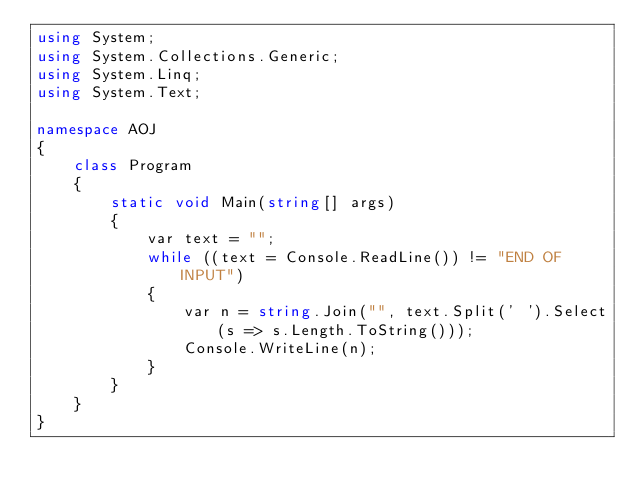<code> <loc_0><loc_0><loc_500><loc_500><_C#_>using System;
using System.Collections.Generic;
using System.Linq;
using System.Text;

namespace AOJ
{
	class Program
	{
		static void Main(string[] args)
		{
			var text = "";
			while ((text = Console.ReadLine()) != "END OF INPUT")
			{
				var n = string.Join("", text.Split(' ').Select(s => s.Length.ToString()));
				Console.WriteLine(n);
			}
		}
	}
}</code> 